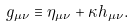Convert formula to latex. <formula><loc_0><loc_0><loc_500><loc_500>g _ { \mu \nu } \equiv \eta _ { \mu \nu } + \kappa h _ { \mu \nu } .</formula> 